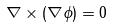Convert formula to latex. <formula><loc_0><loc_0><loc_500><loc_500>\nabla \times ( \nabla \phi ) = 0</formula> 